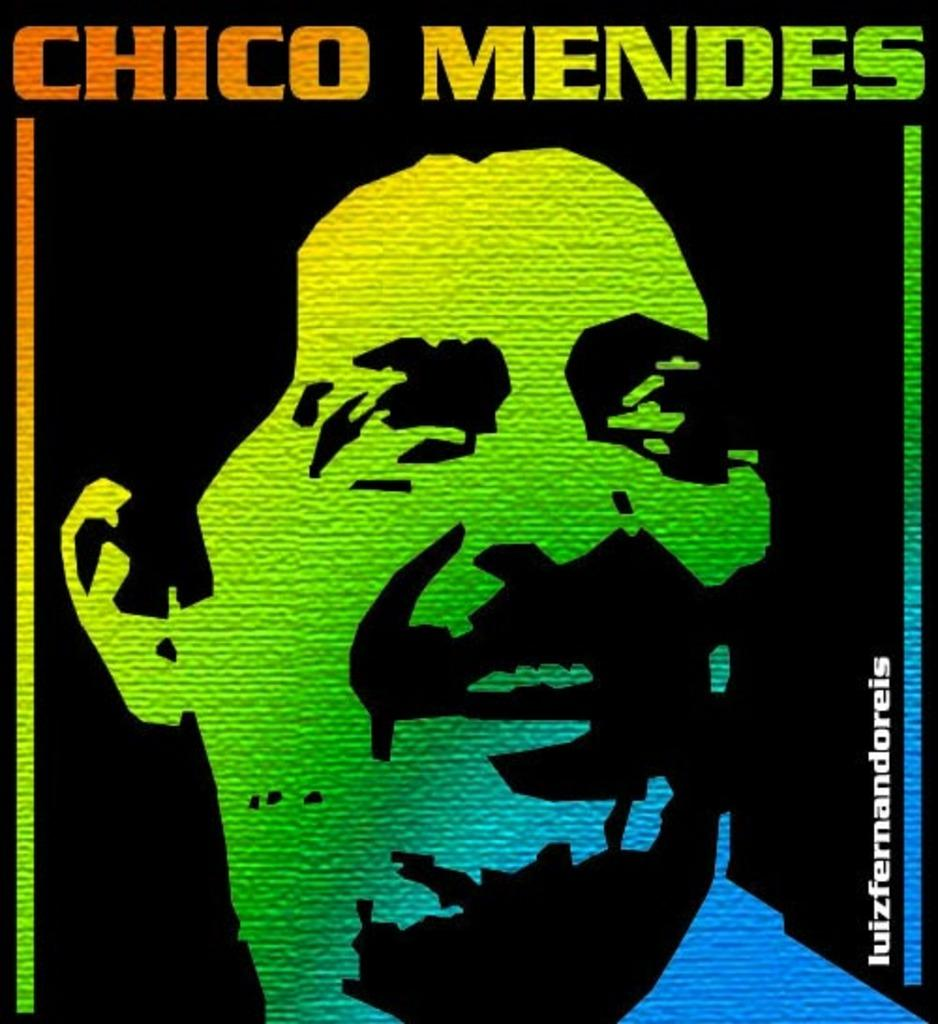<image>
Present a compact description of the photo's key features. a poster of CHICO MENDEZ in colours. 